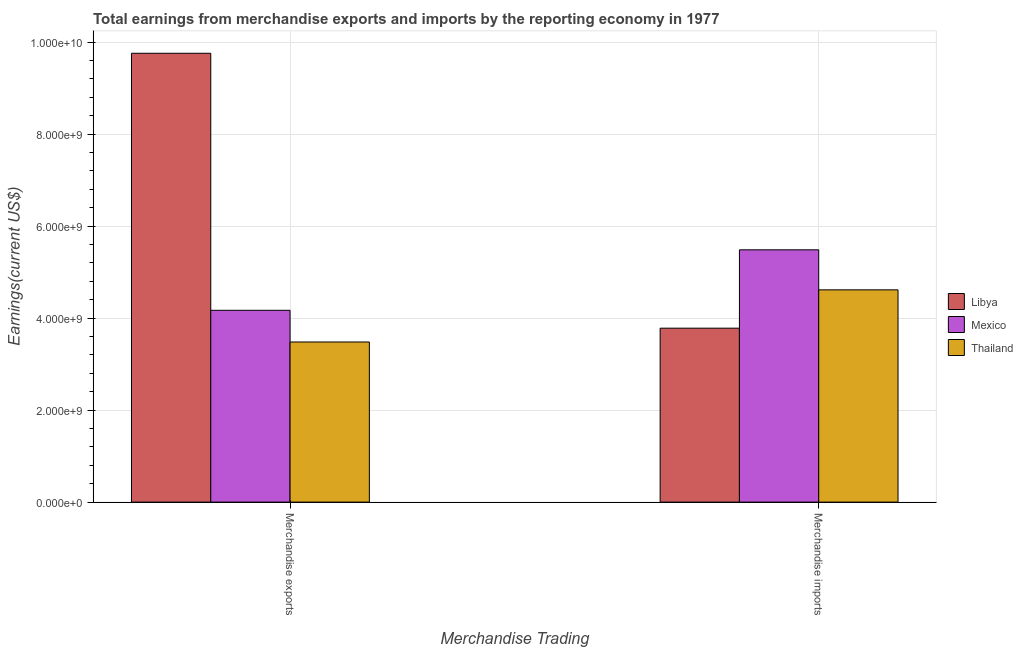How many different coloured bars are there?
Provide a short and direct response. 3. How many groups of bars are there?
Make the answer very short. 2. Are the number of bars per tick equal to the number of legend labels?
Give a very brief answer. Yes. How many bars are there on the 2nd tick from the left?
Your answer should be compact. 3. How many bars are there on the 2nd tick from the right?
Offer a very short reply. 3. What is the earnings from merchandise imports in Mexico?
Your answer should be compact. 5.49e+09. Across all countries, what is the maximum earnings from merchandise imports?
Your answer should be very brief. 5.49e+09. Across all countries, what is the minimum earnings from merchandise imports?
Ensure brevity in your answer.  3.78e+09. In which country was the earnings from merchandise exports minimum?
Offer a terse response. Thailand. What is the total earnings from merchandise imports in the graph?
Ensure brevity in your answer.  1.39e+1. What is the difference between the earnings from merchandise exports in Libya and that in Mexico?
Ensure brevity in your answer.  5.59e+09. What is the difference between the earnings from merchandise imports in Thailand and the earnings from merchandise exports in Mexico?
Provide a short and direct response. 4.45e+08. What is the average earnings from merchandise imports per country?
Offer a terse response. 4.63e+09. What is the difference between the earnings from merchandise exports and earnings from merchandise imports in Libya?
Give a very brief answer. 5.98e+09. What is the ratio of the earnings from merchandise exports in Thailand to that in Libya?
Make the answer very short. 0.36. Is the earnings from merchandise exports in Libya less than that in Mexico?
Your answer should be very brief. No. In how many countries, is the earnings from merchandise exports greater than the average earnings from merchandise exports taken over all countries?
Give a very brief answer. 1. What does the 3rd bar from the left in Merchandise imports represents?
Offer a very short reply. Thailand. What does the 3rd bar from the right in Merchandise exports represents?
Give a very brief answer. Libya. How many bars are there?
Ensure brevity in your answer.  6. Are all the bars in the graph horizontal?
Give a very brief answer. No. What is the difference between two consecutive major ticks on the Y-axis?
Your answer should be compact. 2.00e+09. Are the values on the major ticks of Y-axis written in scientific E-notation?
Give a very brief answer. Yes. Where does the legend appear in the graph?
Your answer should be compact. Center right. How many legend labels are there?
Offer a very short reply. 3. How are the legend labels stacked?
Give a very brief answer. Vertical. What is the title of the graph?
Your response must be concise. Total earnings from merchandise exports and imports by the reporting economy in 1977. What is the label or title of the X-axis?
Offer a terse response. Merchandise Trading. What is the label or title of the Y-axis?
Provide a succinct answer. Earnings(current US$). What is the Earnings(current US$) of Libya in Merchandise exports?
Provide a short and direct response. 9.76e+09. What is the Earnings(current US$) in Mexico in Merchandise exports?
Offer a terse response. 4.17e+09. What is the Earnings(current US$) of Thailand in Merchandise exports?
Offer a terse response. 3.48e+09. What is the Earnings(current US$) in Libya in Merchandise imports?
Your response must be concise. 3.78e+09. What is the Earnings(current US$) of Mexico in Merchandise imports?
Your response must be concise. 5.49e+09. What is the Earnings(current US$) of Thailand in Merchandise imports?
Provide a succinct answer. 4.62e+09. Across all Merchandise Trading, what is the maximum Earnings(current US$) in Libya?
Ensure brevity in your answer.  9.76e+09. Across all Merchandise Trading, what is the maximum Earnings(current US$) in Mexico?
Your response must be concise. 5.49e+09. Across all Merchandise Trading, what is the maximum Earnings(current US$) in Thailand?
Provide a succinct answer. 4.62e+09. Across all Merchandise Trading, what is the minimum Earnings(current US$) of Libya?
Make the answer very short. 3.78e+09. Across all Merchandise Trading, what is the minimum Earnings(current US$) in Mexico?
Your answer should be compact. 4.17e+09. Across all Merchandise Trading, what is the minimum Earnings(current US$) in Thailand?
Provide a succinct answer. 3.48e+09. What is the total Earnings(current US$) of Libya in the graph?
Your answer should be compact. 1.35e+1. What is the total Earnings(current US$) in Mexico in the graph?
Give a very brief answer. 9.66e+09. What is the total Earnings(current US$) of Thailand in the graph?
Your answer should be compact. 8.10e+09. What is the difference between the Earnings(current US$) in Libya in Merchandise exports and that in Merchandise imports?
Your answer should be compact. 5.98e+09. What is the difference between the Earnings(current US$) of Mexico in Merchandise exports and that in Merchandise imports?
Keep it short and to the point. -1.32e+09. What is the difference between the Earnings(current US$) in Thailand in Merchandise exports and that in Merchandise imports?
Provide a short and direct response. -1.13e+09. What is the difference between the Earnings(current US$) in Libya in Merchandise exports and the Earnings(current US$) in Mexico in Merchandise imports?
Keep it short and to the point. 4.27e+09. What is the difference between the Earnings(current US$) in Libya in Merchandise exports and the Earnings(current US$) in Thailand in Merchandise imports?
Offer a terse response. 5.14e+09. What is the difference between the Earnings(current US$) of Mexico in Merchandise exports and the Earnings(current US$) of Thailand in Merchandise imports?
Give a very brief answer. -4.45e+08. What is the average Earnings(current US$) in Libya per Merchandise Trading?
Provide a short and direct response. 6.77e+09. What is the average Earnings(current US$) in Mexico per Merchandise Trading?
Offer a very short reply. 4.83e+09. What is the average Earnings(current US$) of Thailand per Merchandise Trading?
Your answer should be very brief. 4.05e+09. What is the difference between the Earnings(current US$) in Libya and Earnings(current US$) in Mexico in Merchandise exports?
Offer a terse response. 5.59e+09. What is the difference between the Earnings(current US$) in Libya and Earnings(current US$) in Thailand in Merchandise exports?
Provide a succinct answer. 6.28e+09. What is the difference between the Earnings(current US$) in Mexico and Earnings(current US$) in Thailand in Merchandise exports?
Provide a succinct answer. 6.89e+08. What is the difference between the Earnings(current US$) of Libya and Earnings(current US$) of Mexico in Merchandise imports?
Provide a succinct answer. -1.70e+09. What is the difference between the Earnings(current US$) in Libya and Earnings(current US$) in Thailand in Merchandise imports?
Give a very brief answer. -8.33e+08. What is the difference between the Earnings(current US$) in Mexico and Earnings(current US$) in Thailand in Merchandise imports?
Make the answer very short. 8.70e+08. What is the ratio of the Earnings(current US$) in Libya in Merchandise exports to that in Merchandise imports?
Keep it short and to the point. 2.58. What is the ratio of the Earnings(current US$) in Mexico in Merchandise exports to that in Merchandise imports?
Provide a succinct answer. 0.76. What is the ratio of the Earnings(current US$) in Thailand in Merchandise exports to that in Merchandise imports?
Make the answer very short. 0.75. What is the difference between the highest and the second highest Earnings(current US$) of Libya?
Your response must be concise. 5.98e+09. What is the difference between the highest and the second highest Earnings(current US$) of Mexico?
Keep it short and to the point. 1.32e+09. What is the difference between the highest and the second highest Earnings(current US$) of Thailand?
Your answer should be very brief. 1.13e+09. What is the difference between the highest and the lowest Earnings(current US$) in Libya?
Make the answer very short. 5.98e+09. What is the difference between the highest and the lowest Earnings(current US$) of Mexico?
Your answer should be compact. 1.32e+09. What is the difference between the highest and the lowest Earnings(current US$) of Thailand?
Your response must be concise. 1.13e+09. 